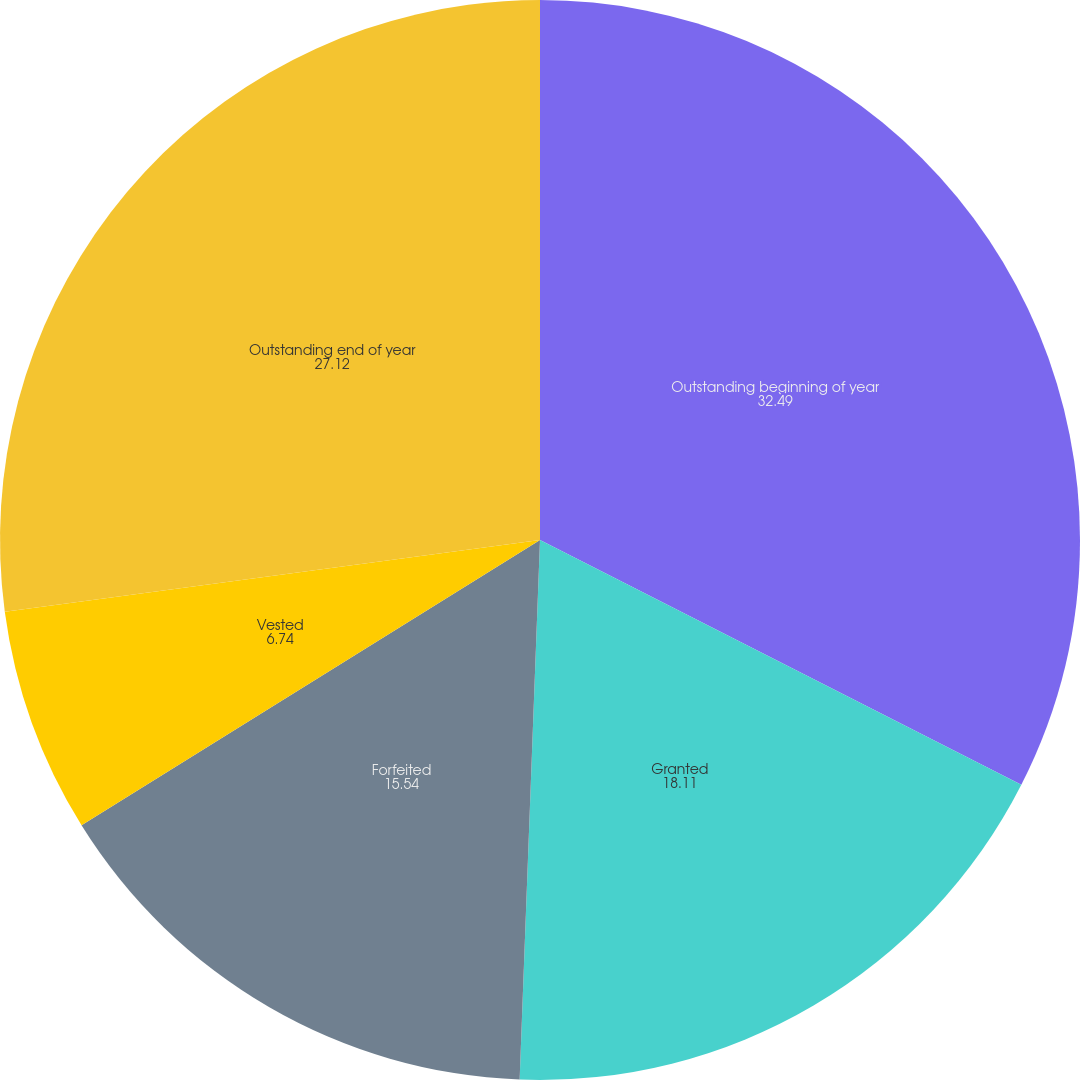<chart> <loc_0><loc_0><loc_500><loc_500><pie_chart><fcel>Outstanding beginning of year<fcel>Granted<fcel>Forfeited<fcel>Vested<fcel>Outstanding end of year<nl><fcel>32.49%<fcel>18.11%<fcel>15.54%<fcel>6.74%<fcel>27.12%<nl></chart> 